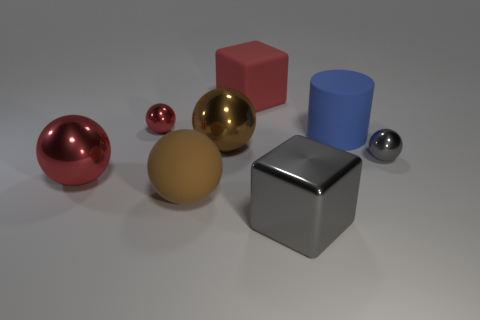Subtract all red spheres. How many spheres are left? 3 Subtract all red spheres. How many spheres are left? 3 Subtract 1 balls. How many balls are left? 4 Subtract all gray balls. Subtract all blue cubes. How many balls are left? 4 Add 1 brown blocks. How many objects exist? 9 Subtract all blocks. How many objects are left? 6 Subtract all matte cylinders. Subtract all big green metal things. How many objects are left? 7 Add 6 big gray cubes. How many big gray cubes are left? 7 Add 5 cyan rubber objects. How many cyan rubber objects exist? 5 Subtract 0 purple spheres. How many objects are left? 8 